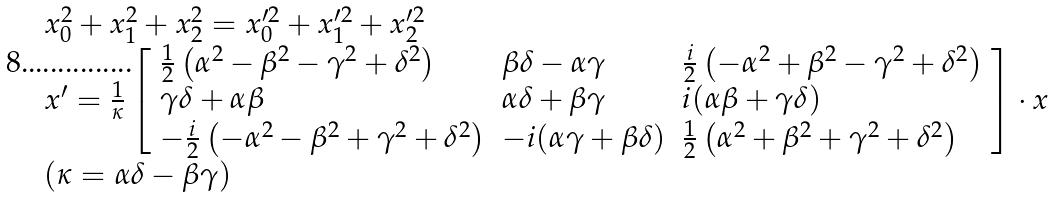<formula> <loc_0><loc_0><loc_500><loc_500>\begin{array} { l } { x _ { 0 } ^ { 2 } + x _ { 1 } ^ { 2 } + x _ { 2 } ^ { 2 } = x _ { 0 } ^ { \prime 2 } + x _ { 1 } ^ { \prime 2 } + x _ { 2 } ^ { \prime 2 } } \\ { x ^ { \prime } = { \frac { 1 } { \kappa } } \left [ { \begin{array} { l l l } { { \frac { 1 } { 2 } } \left ( \alpha ^ { 2 } - \beta ^ { 2 } - \gamma ^ { 2 } + \delta ^ { 2 } \right ) } & { \beta \delta - \alpha \gamma } & { { \frac { i } { 2 } } \left ( - \alpha ^ { 2 } + \beta ^ { 2 } - \gamma ^ { 2 } + \delta ^ { 2 } \right ) } \\ { \gamma \delta + \alpha \beta } & { \alpha \delta + \beta \gamma } & { i ( \alpha \beta + \gamma \delta ) } \\ { - { \frac { i } { 2 } } \left ( - \alpha ^ { 2 } - \beta ^ { 2 } + \gamma ^ { 2 } + \delta ^ { 2 } \right ) } & { - i ( \alpha \gamma + \beta \delta ) } & { { \frac { 1 } { 2 } } \left ( \alpha ^ { 2 } + \beta ^ { 2 } + \gamma ^ { 2 } + \delta ^ { 2 } \right ) } \end{array} } \right ] \cdot x } \\ { ( \kappa = \alpha \delta - \beta \gamma ) } \end{array}</formula> 